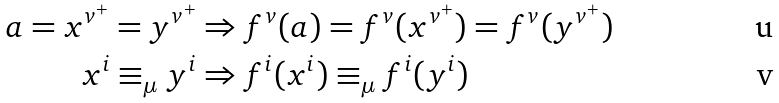Convert formula to latex. <formula><loc_0><loc_0><loc_500><loc_500>a = x ^ { v ^ { + } } = y ^ { v ^ { + } } & \Rightarrow f ^ { v } ( a ) = f ^ { v } ( x ^ { v ^ { + } } ) = f ^ { v } ( y ^ { v ^ { + } } ) \\ x ^ { i } \equiv _ { \mu } y ^ { i } & \Rightarrow f ^ { i } ( x ^ { i } ) \equiv _ { \mu } f ^ { i } ( y ^ { i } )</formula> 